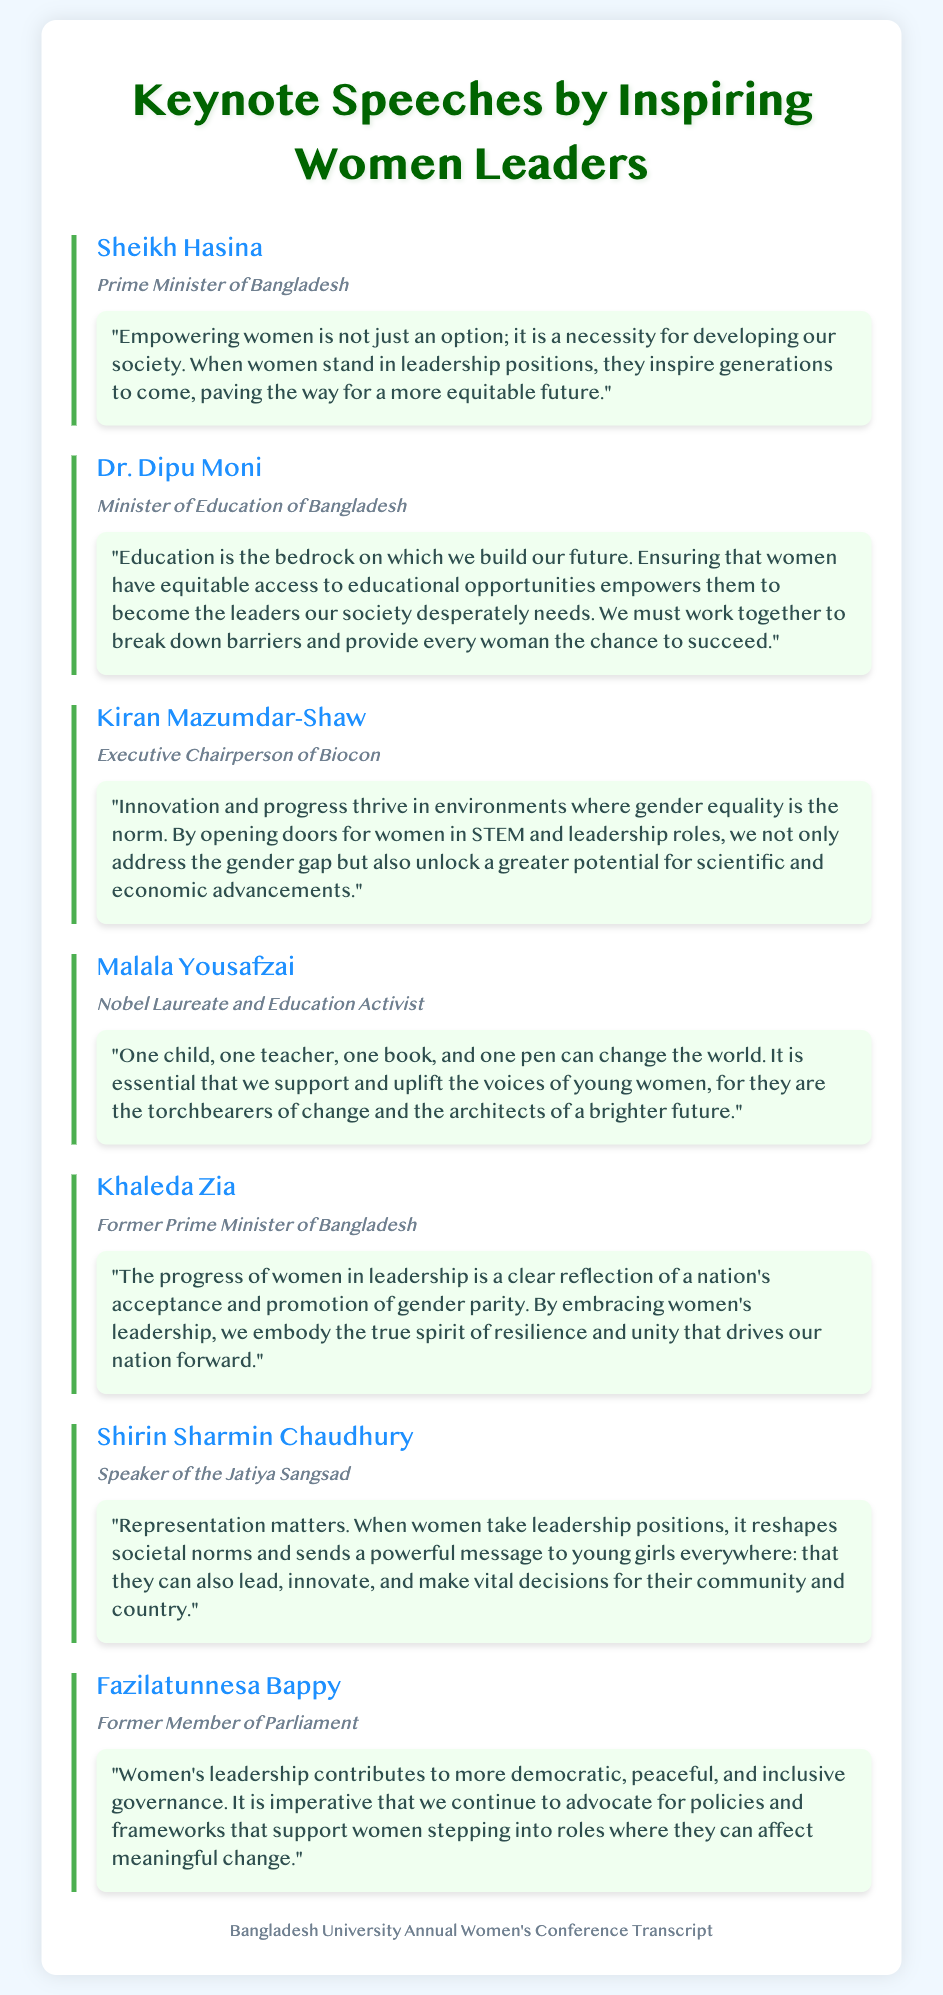what is the name of the Prime Minister of Bangladesh? The document states the name of the Prime Minister of Bangladesh is Sheikh Hasina.
Answer: Sheikh Hasina who spoke about the importance of education for women in leadership? Dr. Dipu Moni highlighted the importance of education for women in her speech at the conference.
Answer: Dr. Dipu Moni what is the main topic addressed by Kiran Mazumdar-Shaw? Kiran Mazumdar-Shaw discussed the importance of gender equality in STEM and leadership roles.
Answer: Gender equality in STEM how many speakers are mentioned in the document? The document lists a total of seven speakers.
Answer: Seven what did Malala Yousafzai emphasize in her speech? Malala Yousafzai emphasized the power of education and the voices of young women.
Answer: Power of education who is the former Member of Parliament mentioned in the transcript? The former Member of Parliament mentioned in the transcript is Fazilatunnesa Bappy.
Answer: Fazilatunnesa Bappy what is a common theme referenced in the speeches? A common theme in the speeches is the empowerment and representation of women in leadership.
Answer: Empowerment and representation what does Khaleda Zia associate with women's leadership? Khaleda Zia associates women's leadership with national resilience and unity.
Answer: Resilience and unity 